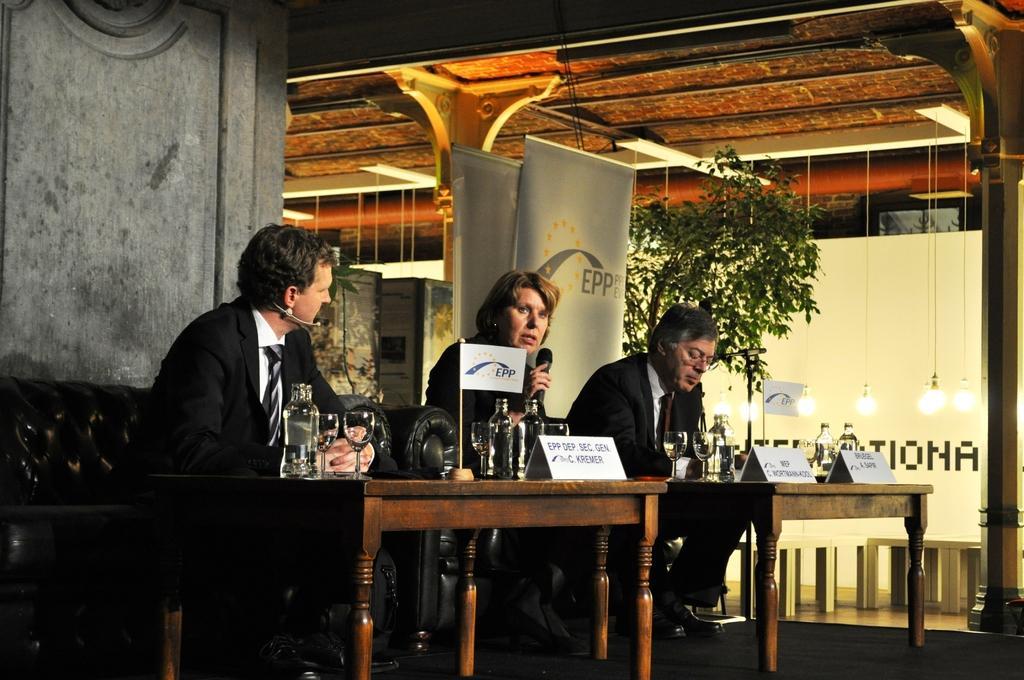Could you give a brief overview of what you see in this image? In the image there are few people sitting on sofas and in front of them there are two tables and on the tables there are glasses, bottles, small flags and behind them there is a wall and beside the wall there are two banners and beside the banners there is a tree and beside the tree there are lights hanging down from the roof. 